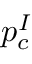Convert formula to latex. <formula><loc_0><loc_0><loc_500><loc_500>p _ { c } ^ { I }</formula> 